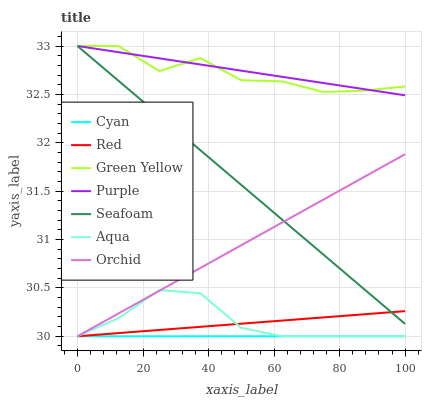Does Cyan have the minimum area under the curve?
Answer yes or no. Yes. Does Purple have the maximum area under the curve?
Answer yes or no. Yes. Does Aqua have the minimum area under the curve?
Answer yes or no. No. Does Aqua have the maximum area under the curve?
Answer yes or no. No. Is Cyan the smoothest?
Answer yes or no. Yes. Is Green Yellow the roughest?
Answer yes or no. Yes. Is Aqua the smoothest?
Answer yes or no. No. Is Aqua the roughest?
Answer yes or no. No. Does Aqua have the lowest value?
Answer yes or no. Yes. Does Seafoam have the lowest value?
Answer yes or no. No. Does Green Yellow have the highest value?
Answer yes or no. Yes. Does Aqua have the highest value?
Answer yes or no. No. Is Red less than Purple?
Answer yes or no. Yes. Is Green Yellow greater than Cyan?
Answer yes or no. Yes. Does Aqua intersect Red?
Answer yes or no. Yes. Is Aqua less than Red?
Answer yes or no. No. Is Aqua greater than Red?
Answer yes or no. No. Does Red intersect Purple?
Answer yes or no. No. 